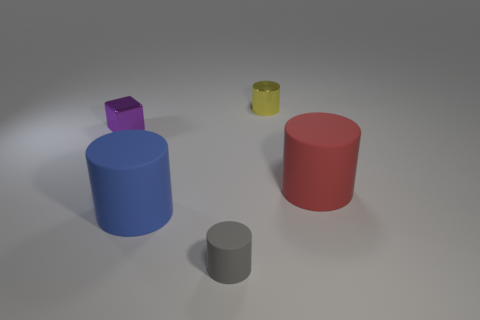Subtract all gray cylinders. How many cylinders are left? 3 Add 1 yellow cubes. How many objects exist? 6 Subtract all yellow cylinders. How many cylinders are left? 3 Subtract 1 cubes. How many cubes are left? 0 Add 5 big blue objects. How many big blue objects are left? 6 Add 5 matte cylinders. How many matte cylinders exist? 8 Subtract 0 brown cylinders. How many objects are left? 5 Subtract all blocks. How many objects are left? 4 Subtract all brown cylinders. Subtract all yellow spheres. How many cylinders are left? 4 Subtract all gray blocks. How many blue cylinders are left? 1 